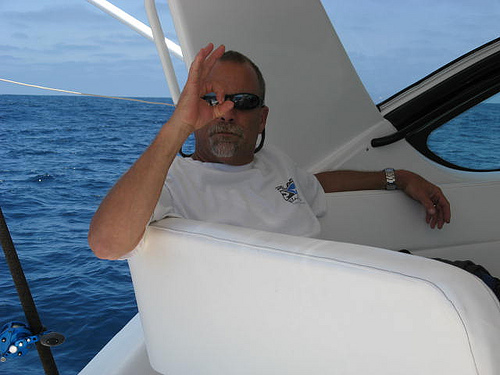<image>
Is the man above the chair? No. The man is not positioned above the chair. The vertical arrangement shows a different relationship. 